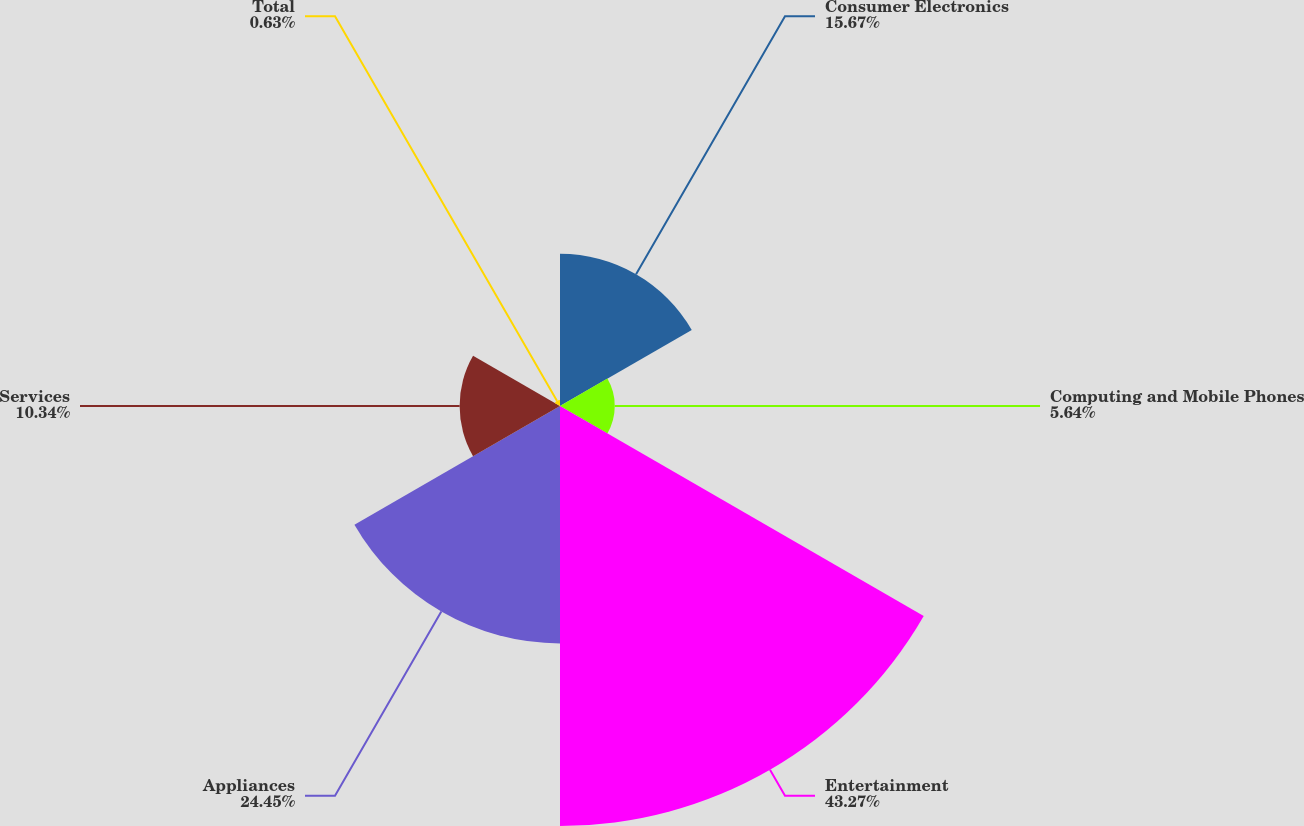<chart> <loc_0><loc_0><loc_500><loc_500><pie_chart><fcel>Consumer Electronics<fcel>Computing and Mobile Phones<fcel>Entertainment<fcel>Appliances<fcel>Services<fcel>Total<nl><fcel>15.67%<fcel>5.64%<fcel>43.26%<fcel>24.45%<fcel>10.34%<fcel>0.63%<nl></chart> 